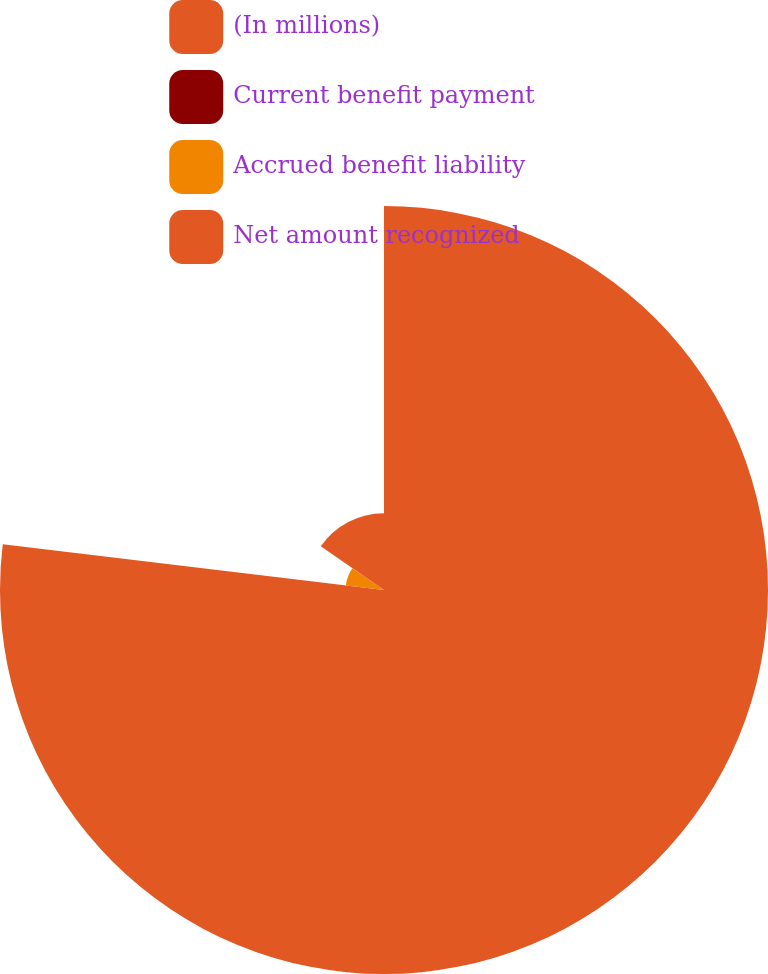Convert chart to OTSL. <chart><loc_0><loc_0><loc_500><loc_500><pie_chart><fcel>(In millions)<fcel>Current benefit payment<fcel>Accrued benefit liability<fcel>Net amount recognized<nl><fcel>76.91%<fcel>0.01%<fcel>7.7%<fcel>15.39%<nl></chart> 